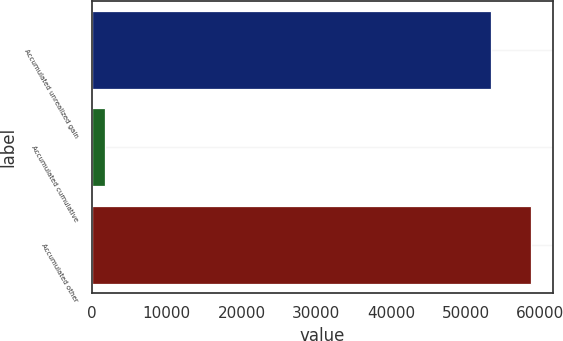Convert chart to OTSL. <chart><loc_0><loc_0><loc_500><loc_500><bar_chart><fcel>Accumulated unrealized gain<fcel>Accumulated cumulative<fcel>Accumulated other<nl><fcel>53375<fcel>1689<fcel>58712.5<nl></chart> 